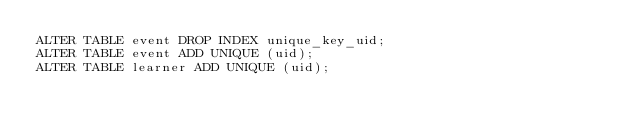Convert code to text. <code><loc_0><loc_0><loc_500><loc_500><_SQL_>ALTER TABLE event DROP INDEX unique_key_uid;
ALTER TABLE event ADD UNIQUE (uid);
ALTER TABLE learner ADD UNIQUE (uid);</code> 